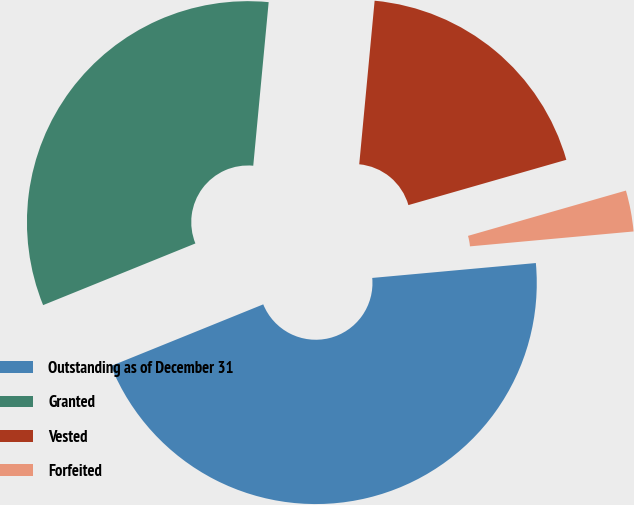Convert chart. <chart><loc_0><loc_0><loc_500><loc_500><pie_chart><fcel>Outstanding as of December 31<fcel>Granted<fcel>Vested<fcel>Forfeited<nl><fcel>45.32%<fcel>32.62%<fcel>19.06%<fcel>3.0%<nl></chart> 